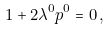Convert formula to latex. <formula><loc_0><loc_0><loc_500><loc_500>1 + 2 \lambda ^ { 0 } p ^ { 0 } = 0 \, ,</formula> 